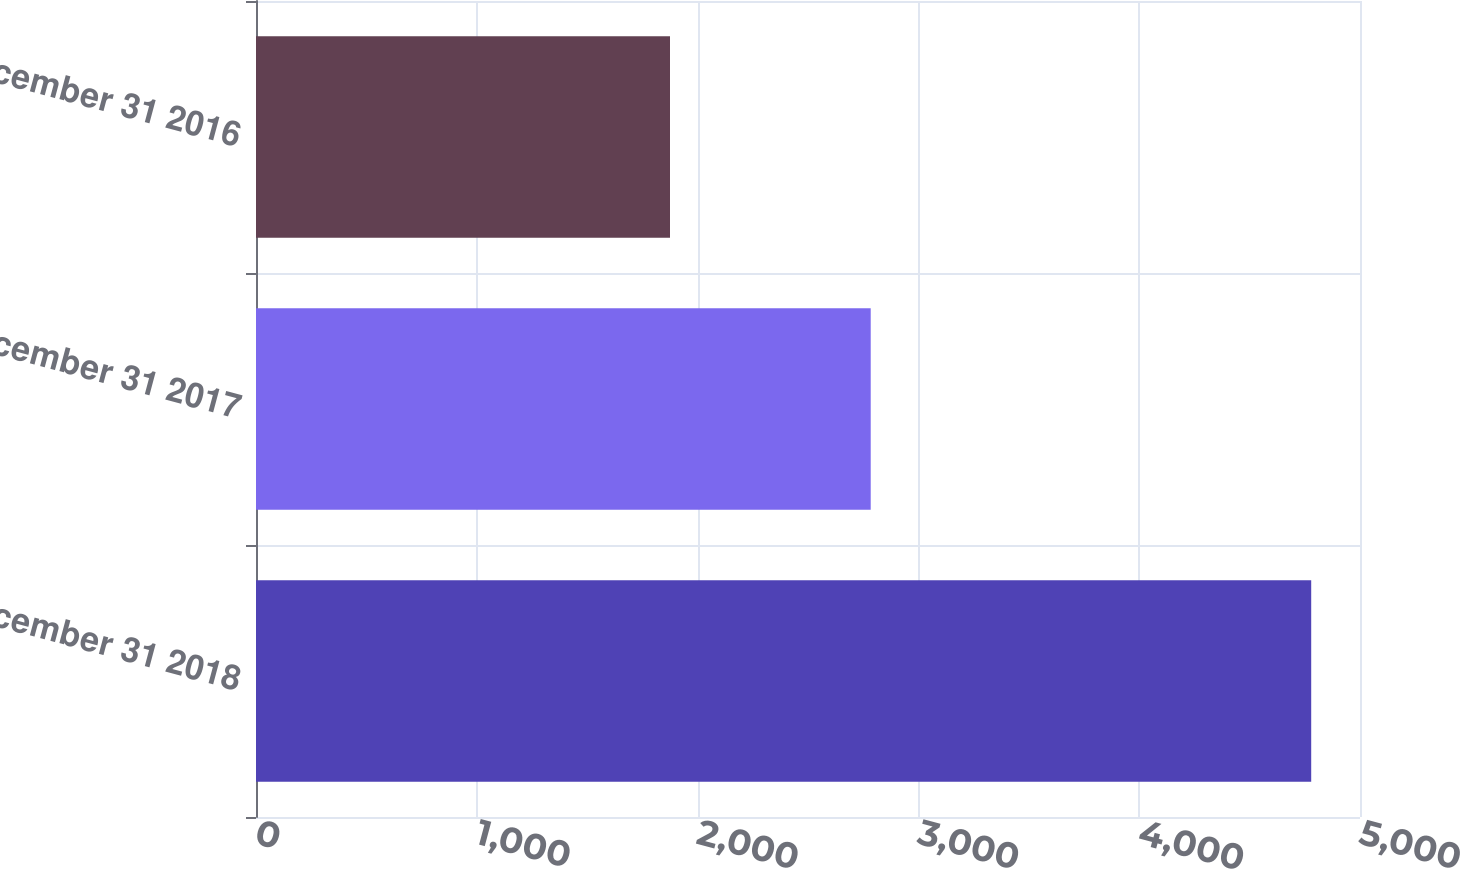Convert chart. <chart><loc_0><loc_0><loc_500><loc_500><bar_chart><fcel>December 31 2018<fcel>December 31 2017<fcel>December 31 2016<nl><fcel>4779<fcel>2784<fcel>1875<nl></chart> 